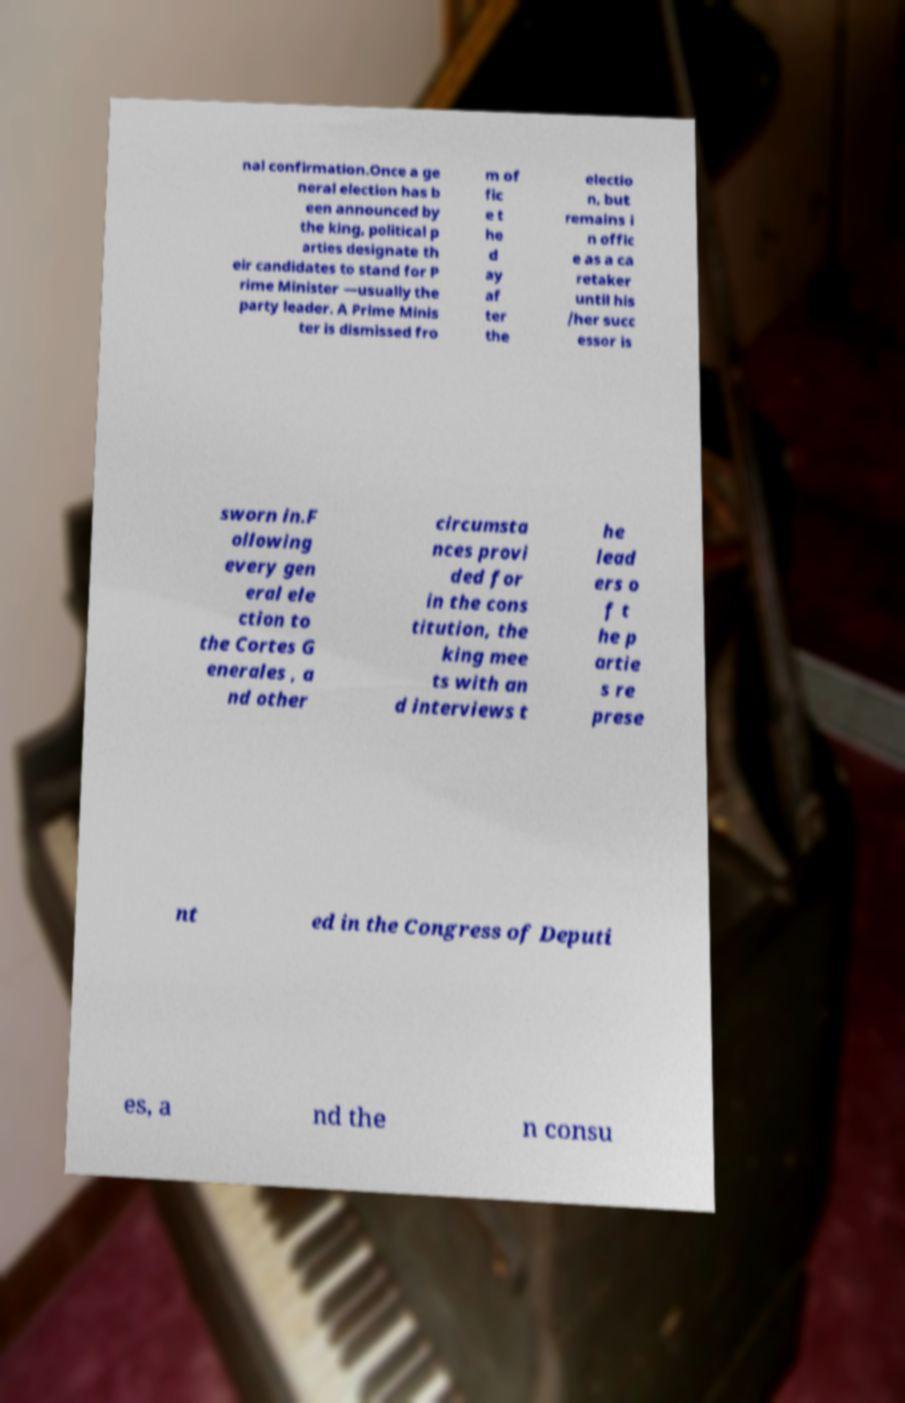I need the written content from this picture converted into text. Can you do that? nal confirmation.Once a ge neral election has b een announced by the king, political p arties designate th eir candidates to stand for P rime Minister —usually the party leader. A Prime Minis ter is dismissed fro m of fic e t he d ay af ter the electio n, but remains i n offic e as a ca retaker until his /her succ essor is sworn in.F ollowing every gen eral ele ction to the Cortes G enerales , a nd other circumsta nces provi ded for in the cons titution, the king mee ts with an d interviews t he lead ers o f t he p artie s re prese nt ed in the Congress of Deputi es, a nd the n consu 